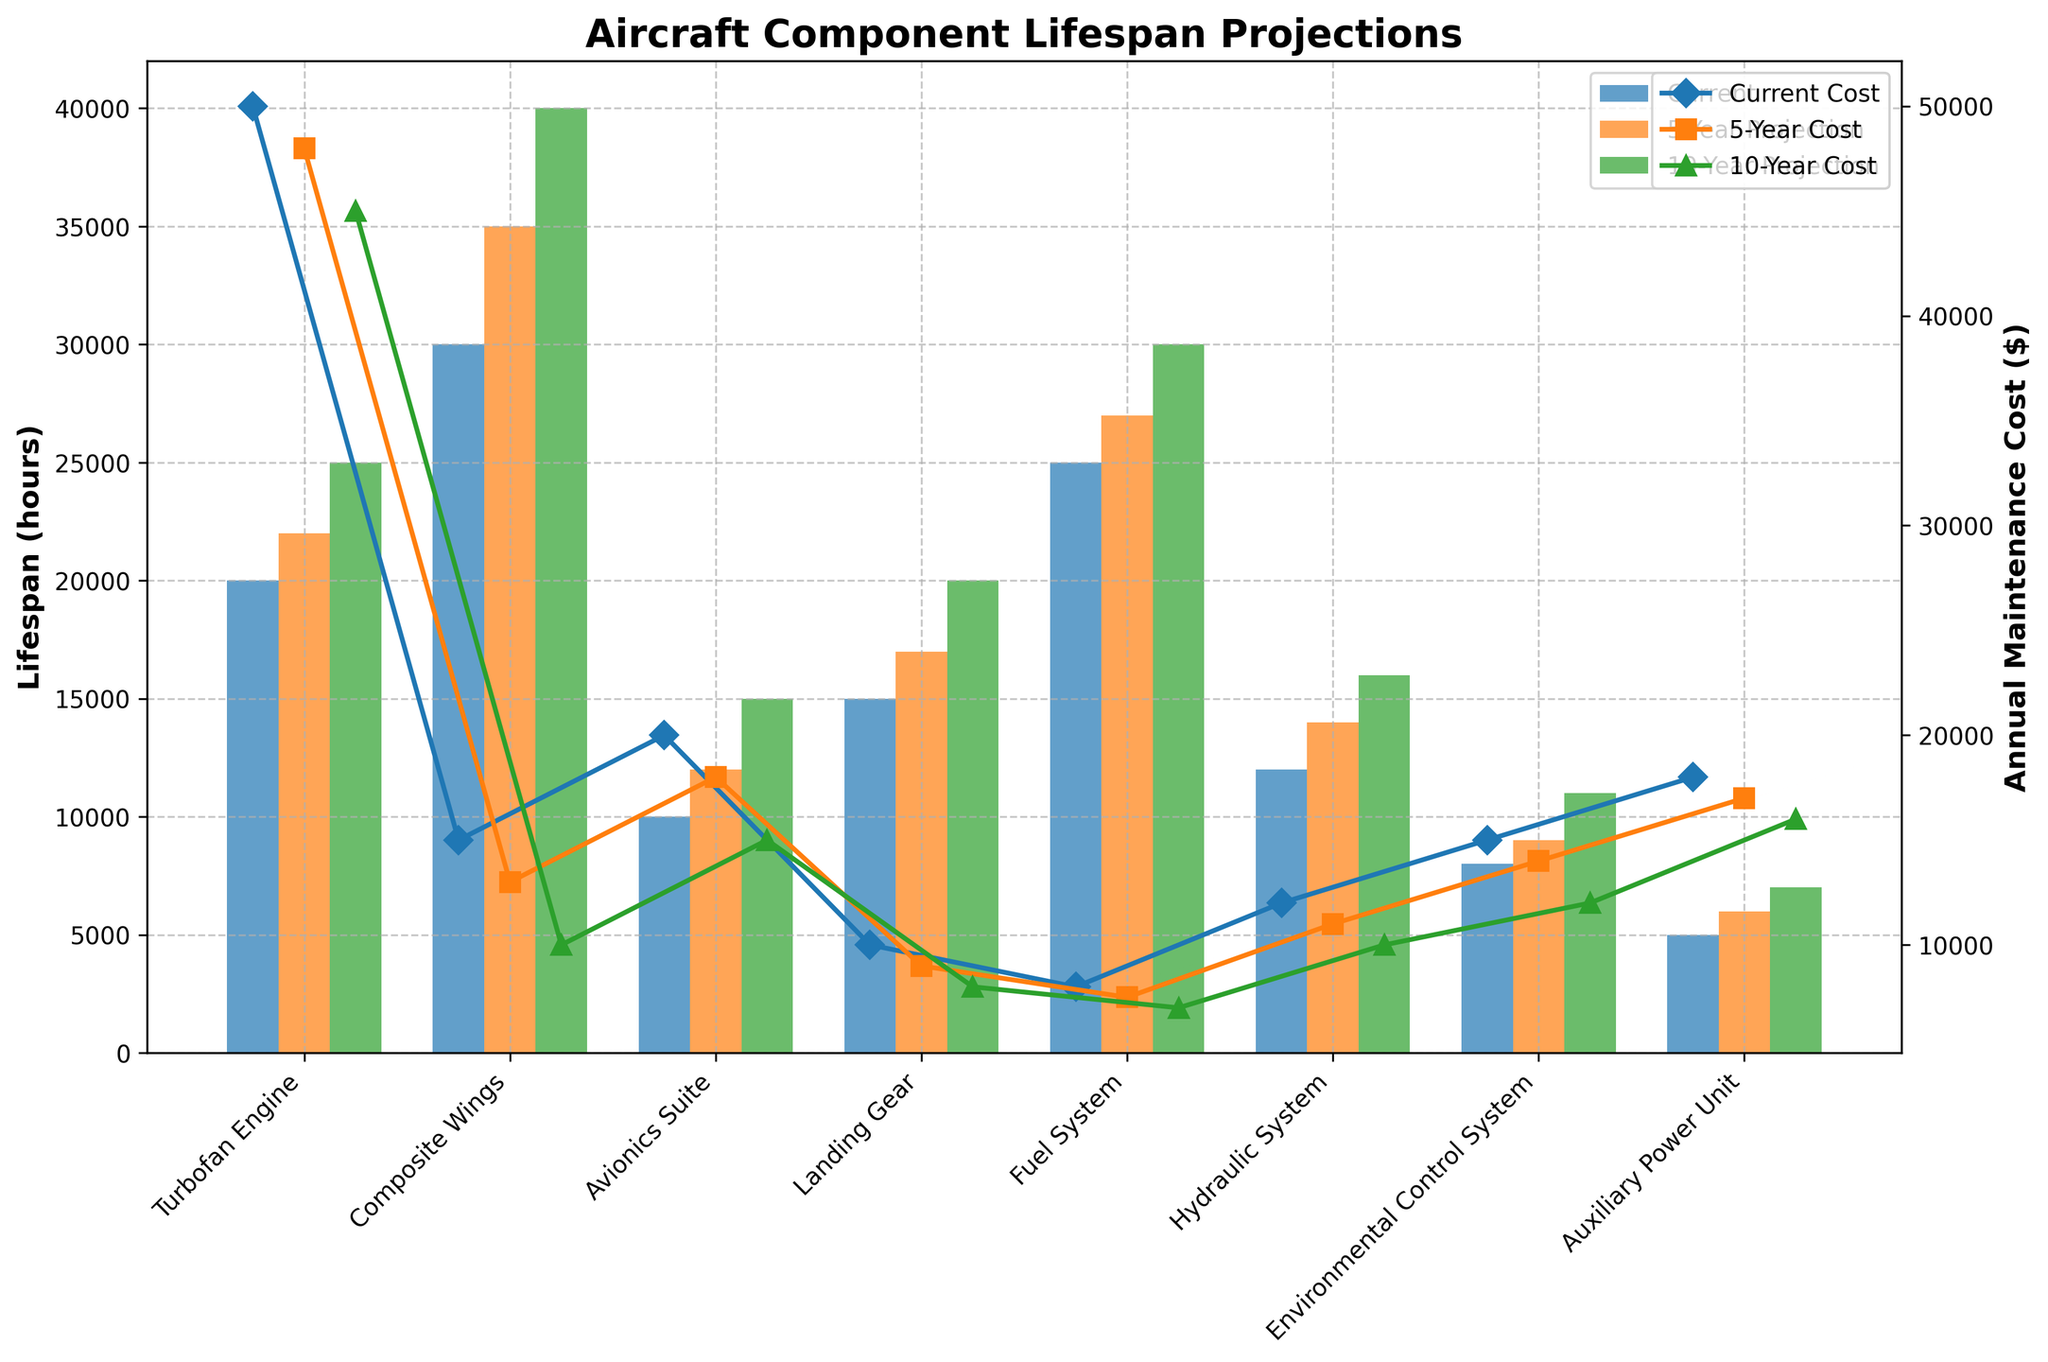What is the lifespan of the turbofan engine currently? The lifespan of the turbofan engine currently is given on the Y-axis in the blue bar. The blue bar labeled "Turbofan Engine" reaches up to 20,000 hours.
Answer: 20,000 hours How does the annual maintenance cost for the auxiliary power unit change over the 10-year projection? To determine the change, note the current cost (blue marker) which is at $18,000, and the 10-year projection cost (green marker) which is at $16,000. The change is $18,000 - $16,000.
Answer: $2,000 decrease Which component has the highest projected lifespan in 10 years? Examine the green bars corresponding to all components; the tallest green bar indicates the highest projected lifespan. The Composite Wings have the highest projected lifespan at 40,000 hours.
Answer: Composite Wings What is the average current lifespan of the landing gear and the environmental control system? Add the current lifespans of the landing gear (15,000 hours) and the environmental control system (8,000 hours) and divide by 2. (15,000 + 8,000) / 2 = 11,500 hours.
Answer: 11,500 hours Compare the projected 5-year and 10-year annual maintenance costs for the avionics suite. Which is lower? Look at the orange marker for the 5-year cost ($18,000) and the green marker for the 10-year cost ($15,000). The 10-year cost is lower.
Answer: 10-year cost For the hydraulic system, what is the difference in the projected lifespans between 5 years and 10 years? Subtract the 5-year projected lifespan (14,000 hours) from the 10-year projected lifespan (16,000 hours). 16,000 - 14,000 = 2,000 hours.
Answer: 2,000 hours Which component sees the greatest reduction in annual maintenance cost from the current to the 10-year projection? Compare the difference in costs for each component from the blue markers to the green markers. The Composite Wings reduce from $15,000 to $10,000, a reduction of $5,000.
Answer: Composite Wings For the environmental control system, what is the proportion of the 5-year projected lifespan to the current lifespan? Divide the 5-year projected lifespan (9,000 hours) by the current lifespan (8,000 hours). 9,000 / 8,000 = 1.125.
Answer: 1.125 How much more is the projected 10-year lifespan of the turbofan engine compared to the current lifespan? Subtract the current lifespan (20,000 hours) from the 10-year projected lifespan (25,000 hours). 25,000 - 20,000 = 5,000 hours.
Answer: 5,000 hours 